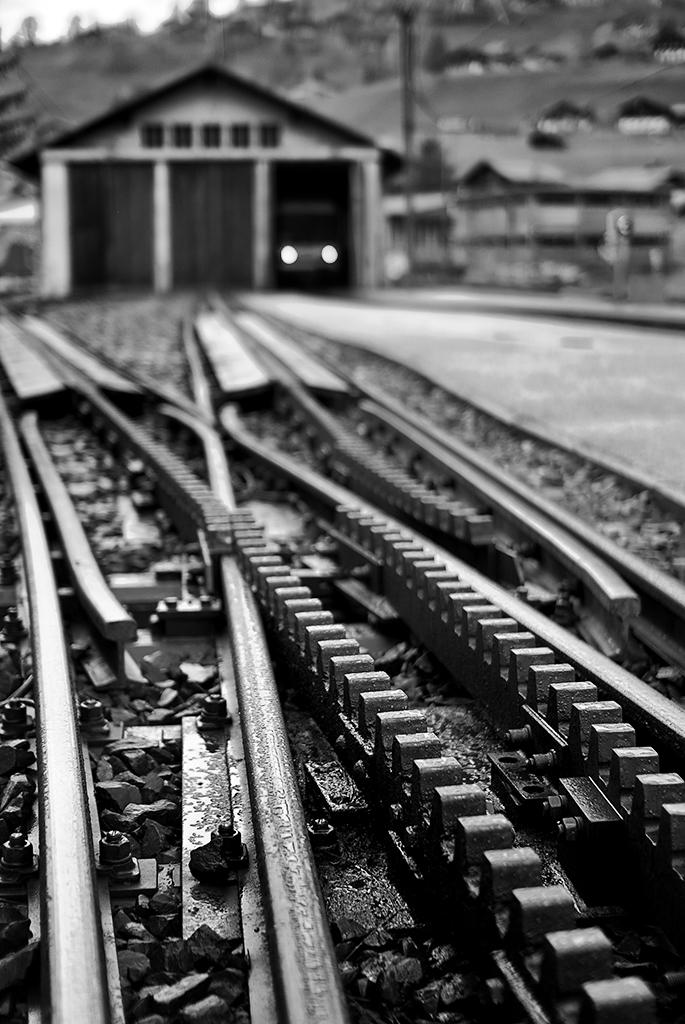What type of transportation infrastructure is present in the image? There are railway tracks in the image. What type of structure can be seen near the railway tracks? There is a shed in the image. What mode of transportation is visible in the image? A vehicle is visible in the image. What type of residential buildings can be seen in the image? There are houses in the image. What song is being sung by the people in the image? There are no people present in the image, so it is not possible to determine what song, if any, is being sung. 